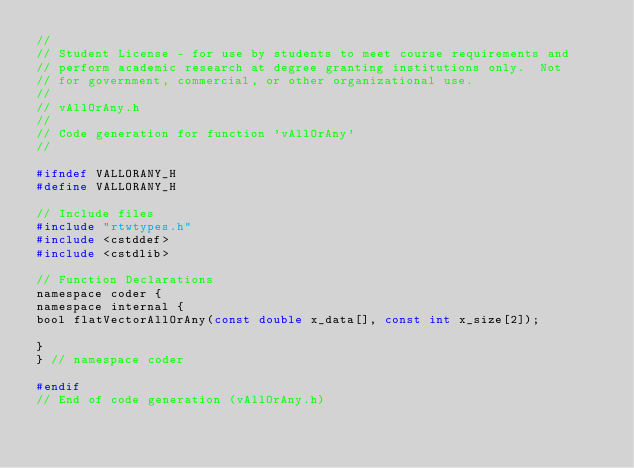<code> <loc_0><loc_0><loc_500><loc_500><_C_>//
// Student License - for use by students to meet course requirements and
// perform academic research at degree granting institutions only.  Not
// for government, commercial, or other organizational use.
//
// vAllOrAny.h
//
// Code generation for function 'vAllOrAny'
//

#ifndef VALLORANY_H
#define VALLORANY_H

// Include files
#include "rtwtypes.h"
#include <cstddef>
#include <cstdlib>

// Function Declarations
namespace coder {
namespace internal {
bool flatVectorAllOrAny(const double x_data[], const int x_size[2]);

}
} // namespace coder

#endif
// End of code generation (vAllOrAny.h)
</code> 